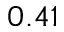<formula> <loc_0><loc_0><loc_500><loc_500>0 . 4 1</formula> 